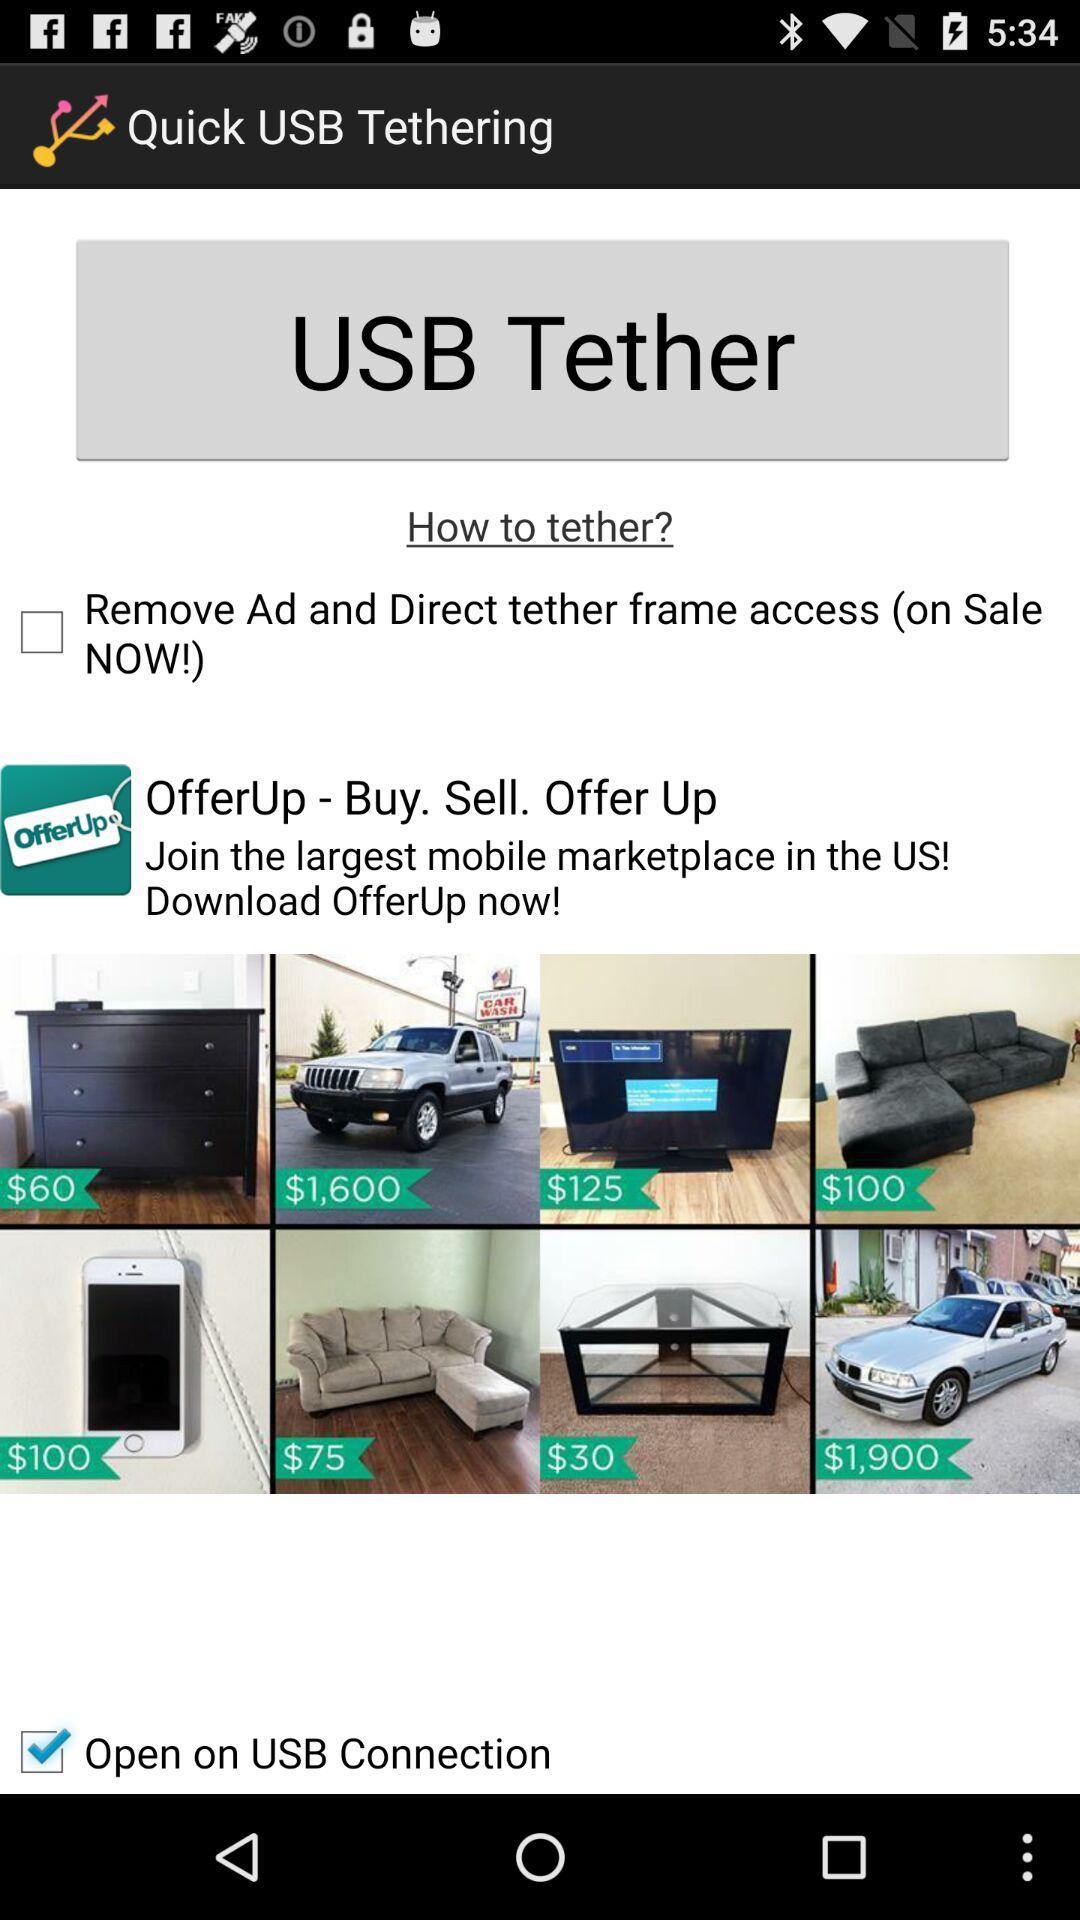Which option is selected for the "USB Tether"? The selected option is "Open on USB Connection". 